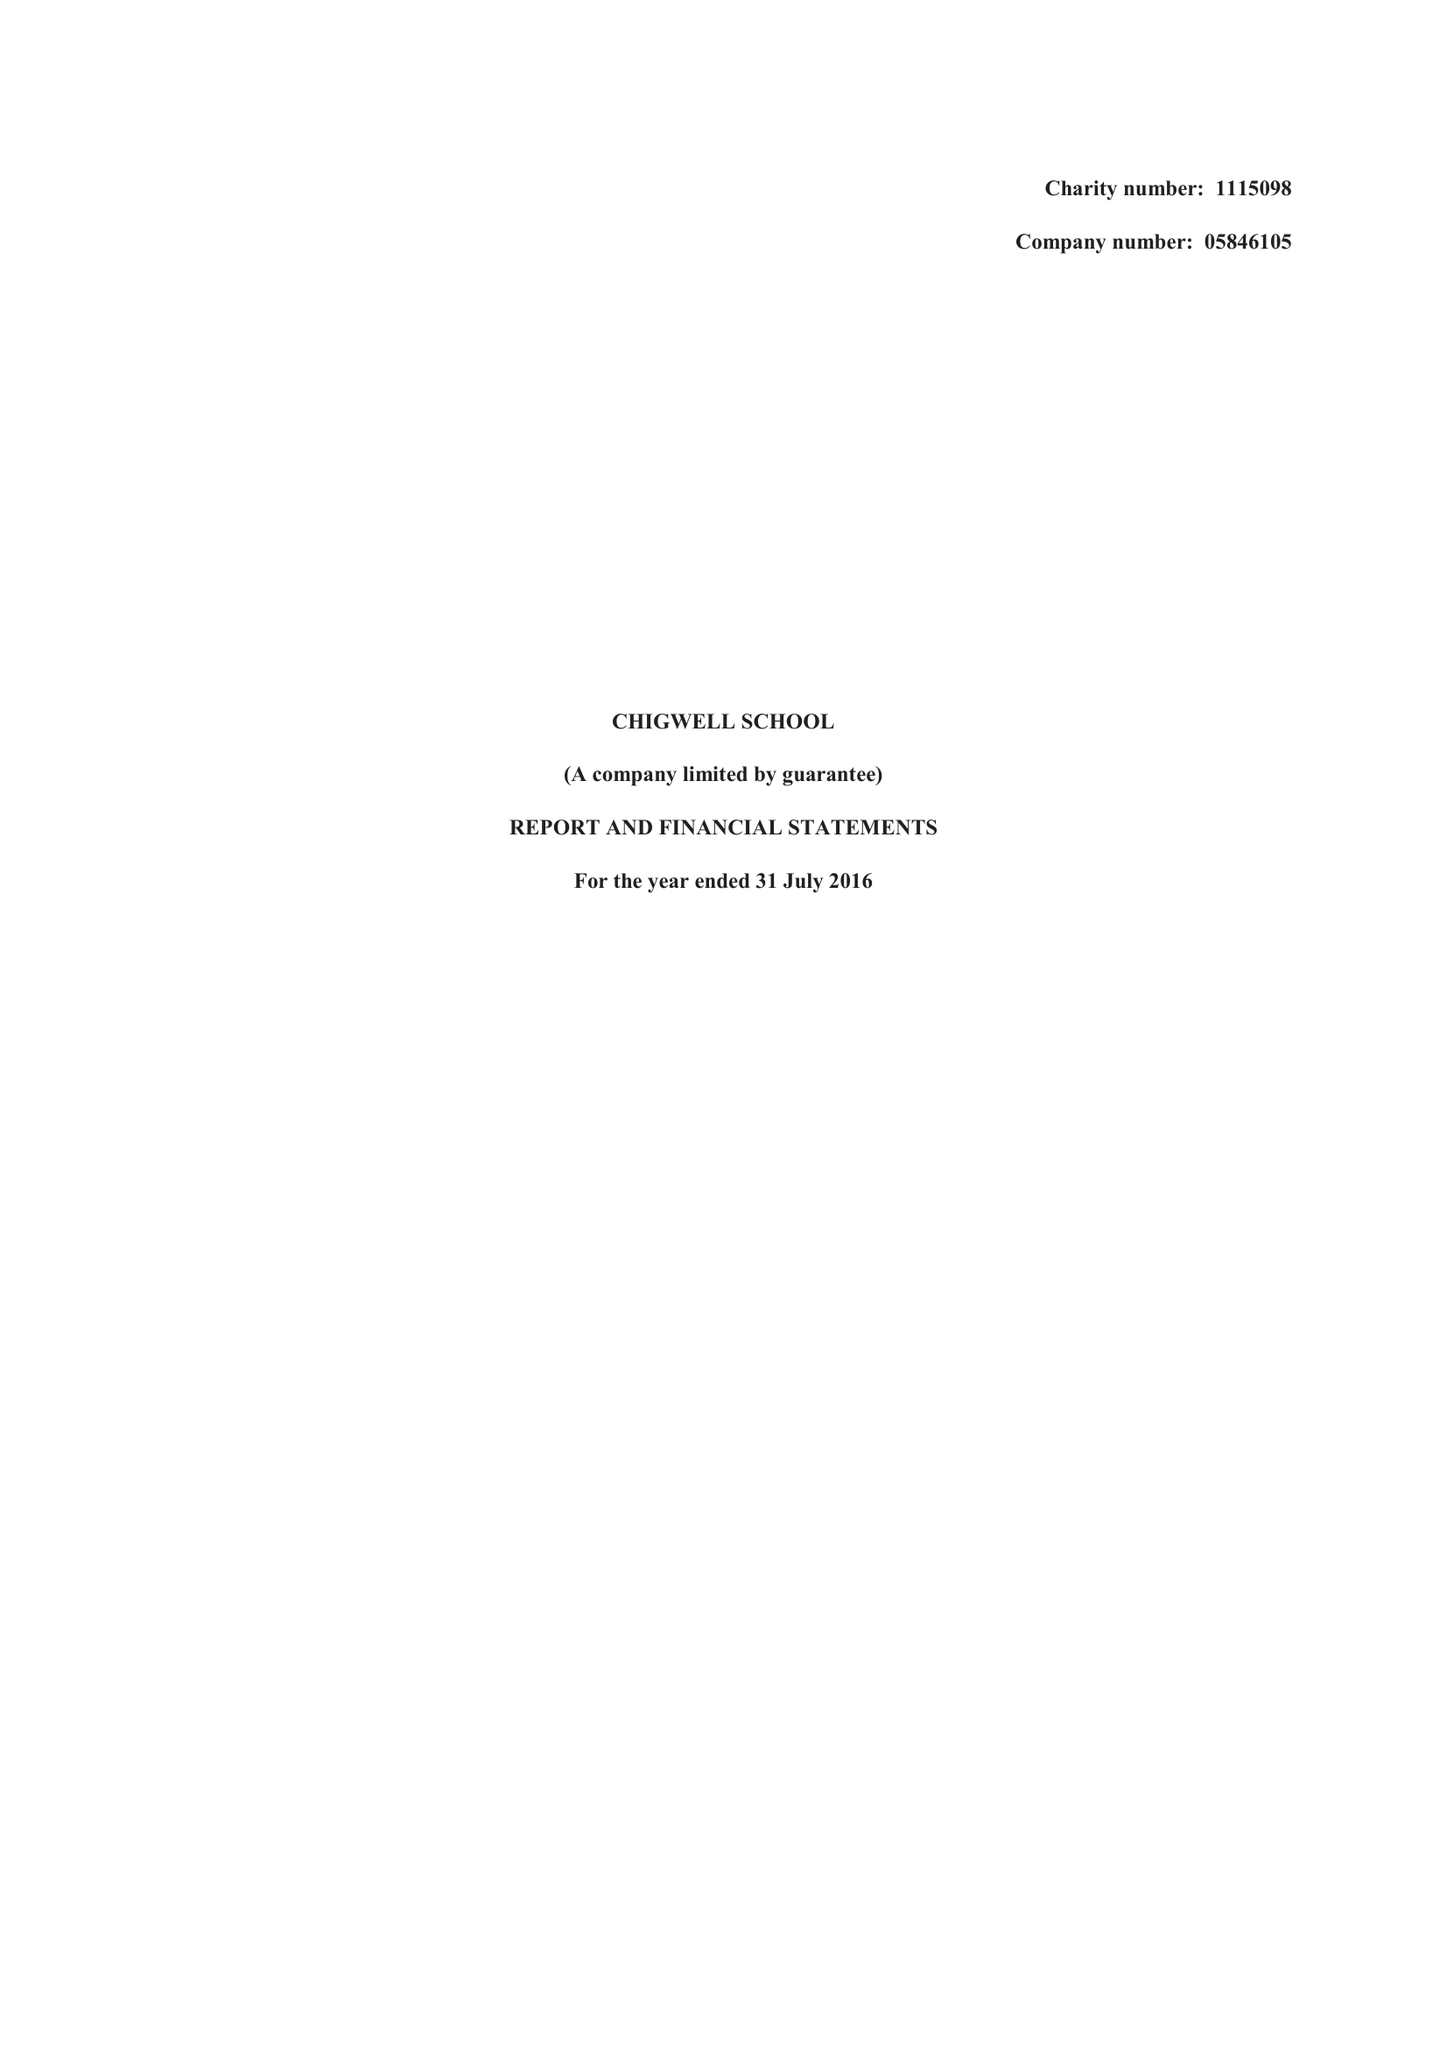What is the value for the report_date?
Answer the question using a single word or phrase. 2016-07-31 